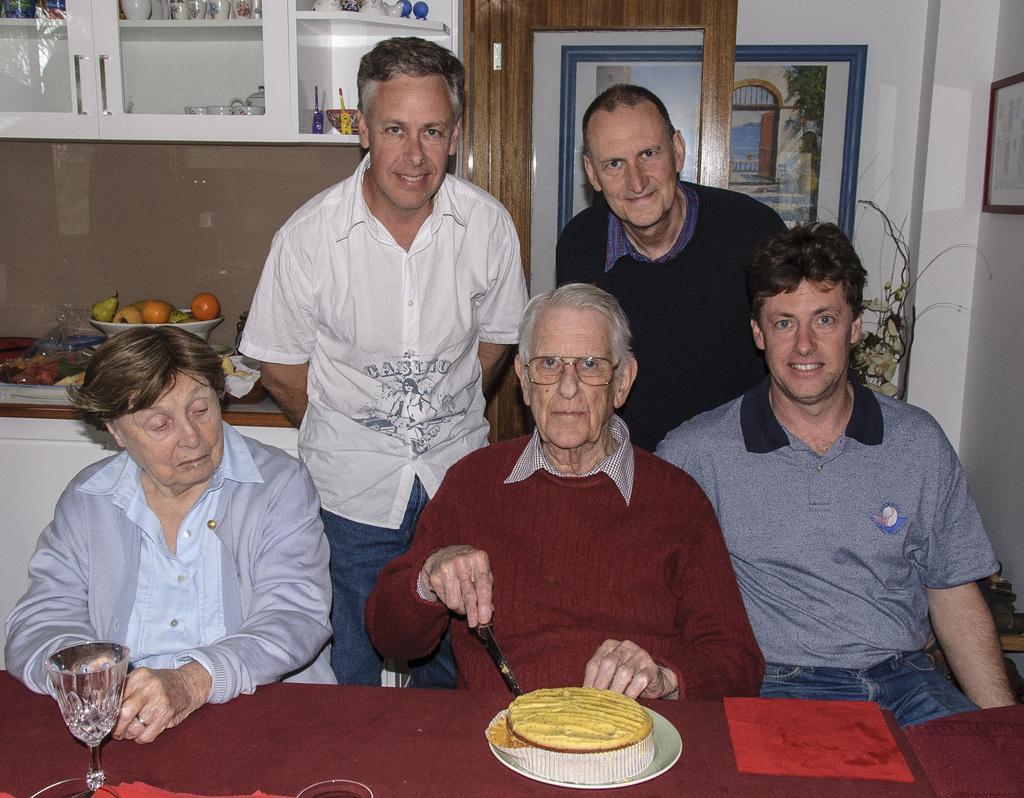Can you describe this image briefly? In this image I see 4 men and a woman and I see that these 3 are sitting and these both are standing and I see that these 3 of them are smiling and I see a table over here on which there is a cake on a white plate and I see a glass over here and I see that this man is holding a knife in his hand. In the background I see the cupboards in which there are few things and I see the fruits in this bowl and I see the wall on which there are photo frames and I see the door over here. 